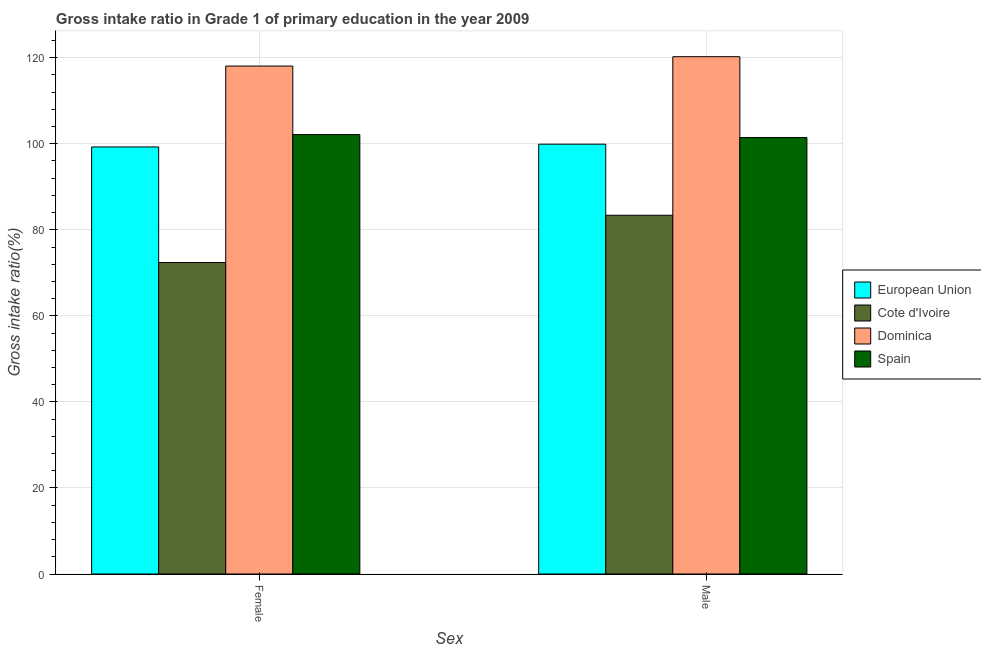How many different coloured bars are there?
Keep it short and to the point. 4. How many groups of bars are there?
Your response must be concise. 2. Are the number of bars on each tick of the X-axis equal?
Keep it short and to the point. Yes. What is the label of the 2nd group of bars from the left?
Make the answer very short. Male. What is the gross intake ratio(female) in European Union?
Provide a short and direct response. 99.26. Across all countries, what is the maximum gross intake ratio(male)?
Offer a very short reply. 120.25. Across all countries, what is the minimum gross intake ratio(female)?
Your answer should be very brief. 72.4. In which country was the gross intake ratio(male) maximum?
Offer a very short reply. Dominica. In which country was the gross intake ratio(male) minimum?
Your response must be concise. Cote d'Ivoire. What is the total gross intake ratio(male) in the graph?
Offer a very short reply. 405. What is the difference between the gross intake ratio(female) in Spain and that in Dominica?
Give a very brief answer. -15.93. What is the difference between the gross intake ratio(male) in European Union and the gross intake ratio(female) in Dominica?
Your answer should be very brief. -18.16. What is the average gross intake ratio(female) per country?
Ensure brevity in your answer.  97.97. What is the difference between the gross intake ratio(male) and gross intake ratio(female) in European Union?
Keep it short and to the point. 0.65. In how many countries, is the gross intake ratio(female) greater than 52 %?
Offer a terse response. 4. What is the ratio of the gross intake ratio(female) in Dominica to that in European Union?
Provide a succinct answer. 1.19. What does the 4th bar from the left in Male represents?
Provide a short and direct response. Spain. What does the 3rd bar from the right in Male represents?
Offer a terse response. Cote d'Ivoire. How many bars are there?
Your answer should be compact. 8. What is the difference between two consecutive major ticks on the Y-axis?
Your response must be concise. 20. Are the values on the major ticks of Y-axis written in scientific E-notation?
Your response must be concise. No. Does the graph contain any zero values?
Give a very brief answer. No. Does the graph contain grids?
Make the answer very short. Yes. Where does the legend appear in the graph?
Keep it short and to the point. Center right. What is the title of the graph?
Provide a short and direct response. Gross intake ratio in Grade 1 of primary education in the year 2009. Does "Angola" appear as one of the legend labels in the graph?
Offer a very short reply. No. What is the label or title of the X-axis?
Your answer should be compact. Sex. What is the label or title of the Y-axis?
Ensure brevity in your answer.  Gross intake ratio(%). What is the Gross intake ratio(%) in European Union in Female?
Make the answer very short. 99.26. What is the Gross intake ratio(%) in Cote d'Ivoire in Female?
Provide a short and direct response. 72.4. What is the Gross intake ratio(%) of Dominica in Female?
Ensure brevity in your answer.  118.07. What is the Gross intake ratio(%) in Spain in Female?
Make the answer very short. 102.14. What is the Gross intake ratio(%) of European Union in Male?
Provide a short and direct response. 99.91. What is the Gross intake ratio(%) in Cote d'Ivoire in Male?
Offer a terse response. 83.39. What is the Gross intake ratio(%) of Dominica in Male?
Your response must be concise. 120.25. What is the Gross intake ratio(%) in Spain in Male?
Ensure brevity in your answer.  101.45. Across all Sex, what is the maximum Gross intake ratio(%) of European Union?
Give a very brief answer. 99.91. Across all Sex, what is the maximum Gross intake ratio(%) of Cote d'Ivoire?
Keep it short and to the point. 83.39. Across all Sex, what is the maximum Gross intake ratio(%) of Dominica?
Offer a very short reply. 120.25. Across all Sex, what is the maximum Gross intake ratio(%) of Spain?
Make the answer very short. 102.14. Across all Sex, what is the minimum Gross intake ratio(%) in European Union?
Your answer should be compact. 99.26. Across all Sex, what is the minimum Gross intake ratio(%) of Cote d'Ivoire?
Make the answer very short. 72.4. Across all Sex, what is the minimum Gross intake ratio(%) in Dominica?
Provide a short and direct response. 118.07. Across all Sex, what is the minimum Gross intake ratio(%) of Spain?
Keep it short and to the point. 101.45. What is the total Gross intake ratio(%) of European Union in the graph?
Keep it short and to the point. 199.18. What is the total Gross intake ratio(%) of Cote d'Ivoire in the graph?
Offer a terse response. 155.79. What is the total Gross intake ratio(%) of Dominica in the graph?
Your answer should be compact. 238.31. What is the total Gross intake ratio(%) in Spain in the graph?
Make the answer very short. 203.59. What is the difference between the Gross intake ratio(%) of European Union in Female and that in Male?
Your answer should be compact. -0.65. What is the difference between the Gross intake ratio(%) in Cote d'Ivoire in Female and that in Male?
Ensure brevity in your answer.  -10.99. What is the difference between the Gross intake ratio(%) in Dominica in Female and that in Male?
Make the answer very short. -2.18. What is the difference between the Gross intake ratio(%) of Spain in Female and that in Male?
Your answer should be compact. 0.69. What is the difference between the Gross intake ratio(%) in European Union in Female and the Gross intake ratio(%) in Cote d'Ivoire in Male?
Provide a short and direct response. 15.87. What is the difference between the Gross intake ratio(%) in European Union in Female and the Gross intake ratio(%) in Dominica in Male?
Give a very brief answer. -20.98. What is the difference between the Gross intake ratio(%) of European Union in Female and the Gross intake ratio(%) of Spain in Male?
Provide a short and direct response. -2.19. What is the difference between the Gross intake ratio(%) of Cote d'Ivoire in Female and the Gross intake ratio(%) of Dominica in Male?
Provide a short and direct response. -47.84. What is the difference between the Gross intake ratio(%) in Cote d'Ivoire in Female and the Gross intake ratio(%) in Spain in Male?
Your answer should be very brief. -29.05. What is the difference between the Gross intake ratio(%) in Dominica in Female and the Gross intake ratio(%) in Spain in Male?
Make the answer very short. 16.62. What is the average Gross intake ratio(%) of European Union per Sex?
Your answer should be very brief. 99.59. What is the average Gross intake ratio(%) in Cote d'Ivoire per Sex?
Ensure brevity in your answer.  77.9. What is the average Gross intake ratio(%) of Dominica per Sex?
Your answer should be very brief. 119.16. What is the average Gross intake ratio(%) of Spain per Sex?
Your answer should be very brief. 101.8. What is the difference between the Gross intake ratio(%) in European Union and Gross intake ratio(%) in Cote d'Ivoire in Female?
Ensure brevity in your answer.  26.86. What is the difference between the Gross intake ratio(%) of European Union and Gross intake ratio(%) of Dominica in Female?
Your response must be concise. -18.8. What is the difference between the Gross intake ratio(%) of European Union and Gross intake ratio(%) of Spain in Female?
Your answer should be compact. -2.88. What is the difference between the Gross intake ratio(%) in Cote d'Ivoire and Gross intake ratio(%) in Dominica in Female?
Your response must be concise. -45.66. What is the difference between the Gross intake ratio(%) in Cote d'Ivoire and Gross intake ratio(%) in Spain in Female?
Your answer should be very brief. -29.74. What is the difference between the Gross intake ratio(%) in Dominica and Gross intake ratio(%) in Spain in Female?
Keep it short and to the point. 15.93. What is the difference between the Gross intake ratio(%) in European Union and Gross intake ratio(%) in Cote d'Ivoire in Male?
Make the answer very short. 16.52. What is the difference between the Gross intake ratio(%) in European Union and Gross intake ratio(%) in Dominica in Male?
Provide a succinct answer. -20.33. What is the difference between the Gross intake ratio(%) of European Union and Gross intake ratio(%) of Spain in Male?
Your answer should be compact. -1.54. What is the difference between the Gross intake ratio(%) of Cote d'Ivoire and Gross intake ratio(%) of Dominica in Male?
Your answer should be very brief. -36.85. What is the difference between the Gross intake ratio(%) of Cote d'Ivoire and Gross intake ratio(%) of Spain in Male?
Give a very brief answer. -18.06. What is the difference between the Gross intake ratio(%) of Dominica and Gross intake ratio(%) of Spain in Male?
Keep it short and to the point. 18.79. What is the ratio of the Gross intake ratio(%) in Cote d'Ivoire in Female to that in Male?
Ensure brevity in your answer.  0.87. What is the ratio of the Gross intake ratio(%) of Dominica in Female to that in Male?
Offer a very short reply. 0.98. What is the ratio of the Gross intake ratio(%) in Spain in Female to that in Male?
Keep it short and to the point. 1.01. What is the difference between the highest and the second highest Gross intake ratio(%) of European Union?
Your answer should be very brief. 0.65. What is the difference between the highest and the second highest Gross intake ratio(%) of Cote d'Ivoire?
Ensure brevity in your answer.  10.99. What is the difference between the highest and the second highest Gross intake ratio(%) in Dominica?
Make the answer very short. 2.18. What is the difference between the highest and the second highest Gross intake ratio(%) of Spain?
Provide a short and direct response. 0.69. What is the difference between the highest and the lowest Gross intake ratio(%) of European Union?
Make the answer very short. 0.65. What is the difference between the highest and the lowest Gross intake ratio(%) in Cote d'Ivoire?
Offer a terse response. 10.99. What is the difference between the highest and the lowest Gross intake ratio(%) of Dominica?
Make the answer very short. 2.18. What is the difference between the highest and the lowest Gross intake ratio(%) of Spain?
Your answer should be very brief. 0.69. 